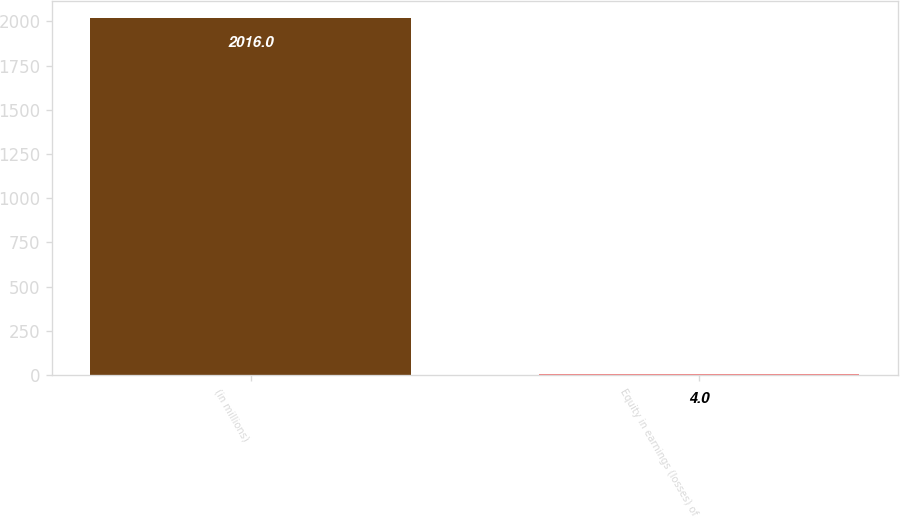Convert chart to OTSL. <chart><loc_0><loc_0><loc_500><loc_500><bar_chart><fcel>(in millions)<fcel>Equity in earnings (losses) of<nl><fcel>2016<fcel>4<nl></chart> 